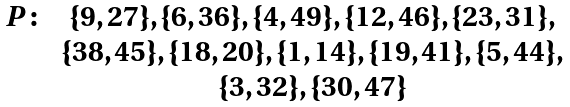<formula> <loc_0><loc_0><loc_500><loc_500>\begin{array} { c c c } P \colon & \{ 9 , 2 7 \} , \{ 6 , 3 6 \} , \{ 4 , 4 9 \} , \{ 1 2 , 4 6 \} , \{ 2 3 , 3 1 \} , \\ & \{ 3 8 , 4 5 \} , \{ 1 8 , 2 0 \} , \{ 1 , 1 4 \} , \{ 1 9 , 4 1 \} , \{ 5 , 4 4 \} , \\ & \{ 3 , 3 2 \} , \{ 3 0 , 4 7 \} \\ \end{array}</formula> 